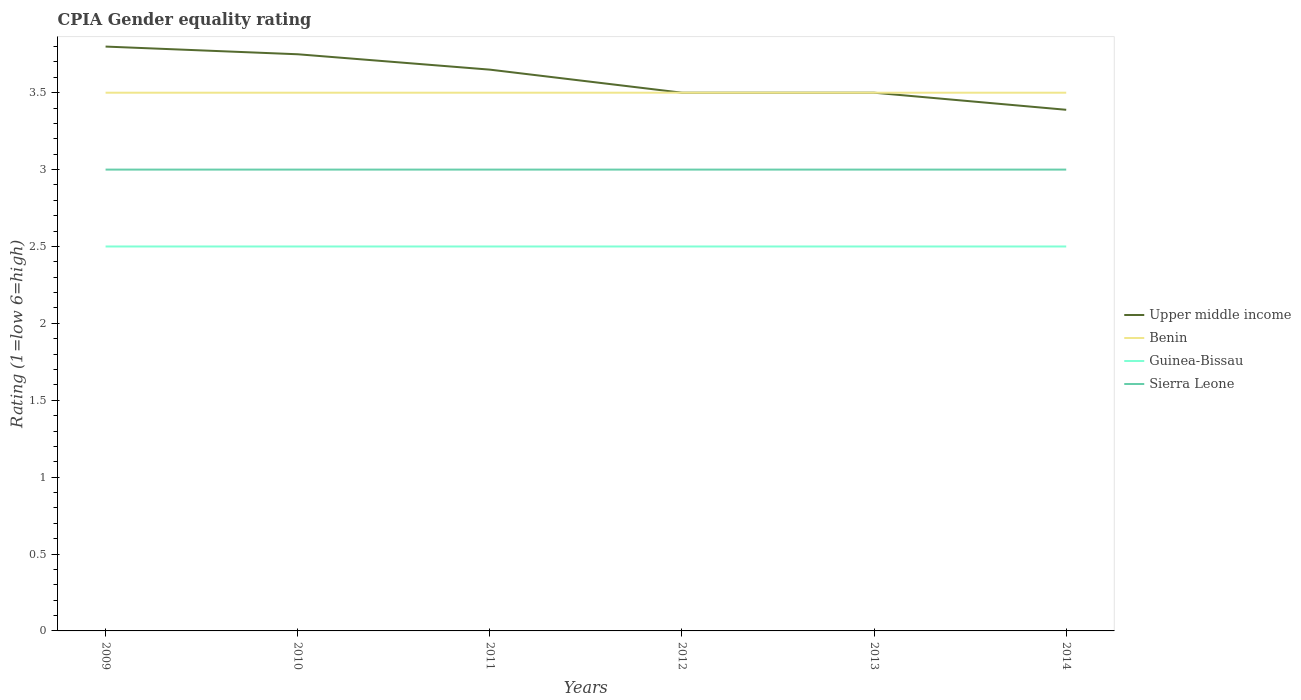Is the number of lines equal to the number of legend labels?
Give a very brief answer. Yes. Across all years, what is the maximum CPIA rating in Upper middle income?
Your response must be concise. 3.39. In which year was the CPIA rating in Upper middle income maximum?
Provide a succinct answer. 2014. What is the total CPIA rating in Benin in the graph?
Your answer should be very brief. 0. What is the difference between the highest and the second highest CPIA rating in Guinea-Bissau?
Make the answer very short. 0. What is the difference between two consecutive major ticks on the Y-axis?
Make the answer very short. 0.5. Does the graph contain grids?
Give a very brief answer. No. Where does the legend appear in the graph?
Provide a succinct answer. Center right. How many legend labels are there?
Keep it short and to the point. 4. How are the legend labels stacked?
Keep it short and to the point. Vertical. What is the title of the graph?
Offer a very short reply. CPIA Gender equality rating. Does "Low & middle income" appear as one of the legend labels in the graph?
Your response must be concise. No. What is the label or title of the X-axis?
Provide a short and direct response. Years. What is the Rating (1=low 6=high) in Upper middle income in 2009?
Give a very brief answer. 3.8. What is the Rating (1=low 6=high) in Guinea-Bissau in 2009?
Offer a terse response. 2.5. What is the Rating (1=low 6=high) of Sierra Leone in 2009?
Your answer should be very brief. 3. What is the Rating (1=low 6=high) in Upper middle income in 2010?
Ensure brevity in your answer.  3.75. What is the Rating (1=low 6=high) of Benin in 2010?
Your answer should be compact. 3.5. What is the Rating (1=low 6=high) of Sierra Leone in 2010?
Provide a succinct answer. 3. What is the Rating (1=low 6=high) in Upper middle income in 2011?
Your answer should be compact. 3.65. What is the Rating (1=low 6=high) in Benin in 2011?
Offer a very short reply. 3.5. What is the Rating (1=low 6=high) in Sierra Leone in 2011?
Offer a terse response. 3. What is the Rating (1=low 6=high) of Sierra Leone in 2012?
Keep it short and to the point. 3. What is the Rating (1=low 6=high) in Upper middle income in 2013?
Keep it short and to the point. 3.5. What is the Rating (1=low 6=high) in Benin in 2013?
Ensure brevity in your answer.  3.5. What is the Rating (1=low 6=high) in Guinea-Bissau in 2013?
Keep it short and to the point. 2.5. What is the Rating (1=low 6=high) of Upper middle income in 2014?
Offer a very short reply. 3.39. Across all years, what is the maximum Rating (1=low 6=high) of Upper middle income?
Offer a terse response. 3.8. Across all years, what is the maximum Rating (1=low 6=high) in Benin?
Offer a terse response. 3.5. Across all years, what is the maximum Rating (1=low 6=high) in Guinea-Bissau?
Your answer should be very brief. 2.5. Across all years, what is the minimum Rating (1=low 6=high) of Upper middle income?
Offer a very short reply. 3.39. Across all years, what is the minimum Rating (1=low 6=high) in Guinea-Bissau?
Provide a succinct answer. 2.5. What is the total Rating (1=low 6=high) in Upper middle income in the graph?
Provide a short and direct response. 21.59. What is the total Rating (1=low 6=high) of Sierra Leone in the graph?
Your answer should be very brief. 18. What is the difference between the Rating (1=low 6=high) in Benin in 2009 and that in 2010?
Provide a succinct answer. 0. What is the difference between the Rating (1=low 6=high) of Upper middle income in 2009 and that in 2011?
Offer a very short reply. 0.15. What is the difference between the Rating (1=low 6=high) in Benin in 2009 and that in 2011?
Give a very brief answer. 0. What is the difference between the Rating (1=low 6=high) of Guinea-Bissau in 2009 and that in 2011?
Your answer should be compact. 0. What is the difference between the Rating (1=low 6=high) in Benin in 2009 and that in 2012?
Keep it short and to the point. 0. What is the difference between the Rating (1=low 6=high) of Sierra Leone in 2009 and that in 2012?
Your answer should be very brief. 0. What is the difference between the Rating (1=low 6=high) of Guinea-Bissau in 2009 and that in 2013?
Provide a short and direct response. 0. What is the difference between the Rating (1=low 6=high) in Upper middle income in 2009 and that in 2014?
Provide a succinct answer. 0.41. What is the difference between the Rating (1=low 6=high) in Benin in 2009 and that in 2014?
Give a very brief answer. 0. What is the difference between the Rating (1=low 6=high) of Guinea-Bissau in 2009 and that in 2014?
Offer a very short reply. 0. What is the difference between the Rating (1=low 6=high) in Sierra Leone in 2009 and that in 2014?
Provide a succinct answer. 0. What is the difference between the Rating (1=low 6=high) of Benin in 2010 and that in 2011?
Offer a very short reply. 0. What is the difference between the Rating (1=low 6=high) of Sierra Leone in 2010 and that in 2011?
Offer a terse response. 0. What is the difference between the Rating (1=low 6=high) of Upper middle income in 2010 and that in 2012?
Your answer should be compact. 0.25. What is the difference between the Rating (1=low 6=high) of Benin in 2010 and that in 2012?
Keep it short and to the point. 0. What is the difference between the Rating (1=low 6=high) of Guinea-Bissau in 2010 and that in 2012?
Provide a short and direct response. 0. What is the difference between the Rating (1=low 6=high) in Benin in 2010 and that in 2013?
Provide a short and direct response. 0. What is the difference between the Rating (1=low 6=high) in Guinea-Bissau in 2010 and that in 2013?
Offer a terse response. 0. What is the difference between the Rating (1=low 6=high) in Sierra Leone in 2010 and that in 2013?
Keep it short and to the point. 0. What is the difference between the Rating (1=low 6=high) of Upper middle income in 2010 and that in 2014?
Offer a very short reply. 0.36. What is the difference between the Rating (1=low 6=high) of Benin in 2010 and that in 2014?
Your answer should be compact. 0. What is the difference between the Rating (1=low 6=high) in Guinea-Bissau in 2010 and that in 2014?
Give a very brief answer. 0. What is the difference between the Rating (1=low 6=high) in Upper middle income in 2011 and that in 2012?
Your response must be concise. 0.15. What is the difference between the Rating (1=low 6=high) in Benin in 2011 and that in 2012?
Offer a terse response. 0. What is the difference between the Rating (1=low 6=high) of Upper middle income in 2011 and that in 2014?
Ensure brevity in your answer.  0.26. What is the difference between the Rating (1=low 6=high) in Upper middle income in 2013 and that in 2014?
Your response must be concise. 0.11. What is the difference between the Rating (1=low 6=high) of Upper middle income in 2009 and the Rating (1=low 6=high) of Benin in 2010?
Ensure brevity in your answer.  0.3. What is the difference between the Rating (1=low 6=high) in Upper middle income in 2009 and the Rating (1=low 6=high) in Sierra Leone in 2010?
Provide a short and direct response. 0.8. What is the difference between the Rating (1=low 6=high) of Upper middle income in 2009 and the Rating (1=low 6=high) of Benin in 2011?
Keep it short and to the point. 0.3. What is the difference between the Rating (1=low 6=high) in Upper middle income in 2009 and the Rating (1=low 6=high) in Guinea-Bissau in 2011?
Your answer should be very brief. 1.3. What is the difference between the Rating (1=low 6=high) of Benin in 2009 and the Rating (1=low 6=high) of Sierra Leone in 2011?
Your answer should be very brief. 0.5. What is the difference between the Rating (1=low 6=high) of Upper middle income in 2009 and the Rating (1=low 6=high) of Guinea-Bissau in 2012?
Offer a very short reply. 1.3. What is the difference between the Rating (1=low 6=high) of Benin in 2009 and the Rating (1=low 6=high) of Guinea-Bissau in 2012?
Ensure brevity in your answer.  1. What is the difference between the Rating (1=low 6=high) of Benin in 2009 and the Rating (1=low 6=high) of Sierra Leone in 2012?
Make the answer very short. 0.5. What is the difference between the Rating (1=low 6=high) of Upper middle income in 2009 and the Rating (1=low 6=high) of Benin in 2013?
Provide a succinct answer. 0.3. What is the difference between the Rating (1=low 6=high) of Upper middle income in 2009 and the Rating (1=low 6=high) of Guinea-Bissau in 2013?
Provide a succinct answer. 1.3. What is the difference between the Rating (1=low 6=high) in Benin in 2009 and the Rating (1=low 6=high) in Guinea-Bissau in 2013?
Your answer should be very brief. 1. What is the difference between the Rating (1=low 6=high) in Benin in 2009 and the Rating (1=low 6=high) in Sierra Leone in 2013?
Your answer should be very brief. 0.5. What is the difference between the Rating (1=low 6=high) in Benin in 2009 and the Rating (1=low 6=high) in Guinea-Bissau in 2014?
Offer a terse response. 1. What is the difference between the Rating (1=low 6=high) in Guinea-Bissau in 2009 and the Rating (1=low 6=high) in Sierra Leone in 2014?
Give a very brief answer. -0.5. What is the difference between the Rating (1=low 6=high) of Upper middle income in 2010 and the Rating (1=low 6=high) of Sierra Leone in 2011?
Provide a succinct answer. 0.75. What is the difference between the Rating (1=low 6=high) in Benin in 2010 and the Rating (1=low 6=high) in Sierra Leone in 2011?
Your response must be concise. 0.5. What is the difference between the Rating (1=low 6=high) of Guinea-Bissau in 2010 and the Rating (1=low 6=high) of Sierra Leone in 2011?
Ensure brevity in your answer.  -0.5. What is the difference between the Rating (1=low 6=high) of Upper middle income in 2010 and the Rating (1=low 6=high) of Benin in 2012?
Provide a succinct answer. 0.25. What is the difference between the Rating (1=low 6=high) in Upper middle income in 2010 and the Rating (1=low 6=high) in Sierra Leone in 2012?
Offer a very short reply. 0.75. What is the difference between the Rating (1=low 6=high) in Benin in 2010 and the Rating (1=low 6=high) in Sierra Leone in 2012?
Offer a very short reply. 0.5. What is the difference between the Rating (1=low 6=high) in Guinea-Bissau in 2010 and the Rating (1=low 6=high) in Sierra Leone in 2012?
Your answer should be very brief. -0.5. What is the difference between the Rating (1=low 6=high) in Upper middle income in 2010 and the Rating (1=low 6=high) in Benin in 2013?
Your response must be concise. 0.25. What is the difference between the Rating (1=low 6=high) of Upper middle income in 2010 and the Rating (1=low 6=high) of Guinea-Bissau in 2013?
Provide a succinct answer. 1.25. What is the difference between the Rating (1=low 6=high) in Benin in 2010 and the Rating (1=low 6=high) in Guinea-Bissau in 2013?
Offer a very short reply. 1. What is the difference between the Rating (1=low 6=high) in Benin in 2010 and the Rating (1=low 6=high) in Guinea-Bissau in 2014?
Make the answer very short. 1. What is the difference between the Rating (1=low 6=high) in Benin in 2010 and the Rating (1=low 6=high) in Sierra Leone in 2014?
Provide a short and direct response. 0.5. What is the difference between the Rating (1=low 6=high) of Guinea-Bissau in 2010 and the Rating (1=low 6=high) of Sierra Leone in 2014?
Your answer should be compact. -0.5. What is the difference between the Rating (1=low 6=high) of Upper middle income in 2011 and the Rating (1=low 6=high) of Guinea-Bissau in 2012?
Offer a very short reply. 1.15. What is the difference between the Rating (1=low 6=high) of Upper middle income in 2011 and the Rating (1=low 6=high) of Sierra Leone in 2012?
Keep it short and to the point. 0.65. What is the difference between the Rating (1=low 6=high) in Benin in 2011 and the Rating (1=low 6=high) in Sierra Leone in 2012?
Keep it short and to the point. 0.5. What is the difference between the Rating (1=low 6=high) in Upper middle income in 2011 and the Rating (1=low 6=high) in Benin in 2013?
Keep it short and to the point. 0.15. What is the difference between the Rating (1=low 6=high) in Upper middle income in 2011 and the Rating (1=low 6=high) in Guinea-Bissau in 2013?
Offer a very short reply. 1.15. What is the difference between the Rating (1=low 6=high) in Upper middle income in 2011 and the Rating (1=low 6=high) in Sierra Leone in 2013?
Offer a terse response. 0.65. What is the difference between the Rating (1=low 6=high) of Benin in 2011 and the Rating (1=low 6=high) of Guinea-Bissau in 2013?
Provide a short and direct response. 1. What is the difference between the Rating (1=low 6=high) of Guinea-Bissau in 2011 and the Rating (1=low 6=high) of Sierra Leone in 2013?
Your response must be concise. -0.5. What is the difference between the Rating (1=low 6=high) in Upper middle income in 2011 and the Rating (1=low 6=high) in Guinea-Bissau in 2014?
Your response must be concise. 1.15. What is the difference between the Rating (1=low 6=high) of Upper middle income in 2011 and the Rating (1=low 6=high) of Sierra Leone in 2014?
Keep it short and to the point. 0.65. What is the difference between the Rating (1=low 6=high) of Benin in 2011 and the Rating (1=low 6=high) of Guinea-Bissau in 2014?
Make the answer very short. 1. What is the difference between the Rating (1=low 6=high) in Guinea-Bissau in 2011 and the Rating (1=low 6=high) in Sierra Leone in 2014?
Keep it short and to the point. -0.5. What is the difference between the Rating (1=low 6=high) in Upper middle income in 2012 and the Rating (1=low 6=high) in Benin in 2013?
Provide a short and direct response. 0. What is the difference between the Rating (1=low 6=high) in Upper middle income in 2012 and the Rating (1=low 6=high) in Sierra Leone in 2013?
Your answer should be very brief. 0.5. What is the difference between the Rating (1=low 6=high) of Benin in 2012 and the Rating (1=low 6=high) of Guinea-Bissau in 2013?
Offer a terse response. 1. What is the difference between the Rating (1=low 6=high) in Benin in 2012 and the Rating (1=low 6=high) in Sierra Leone in 2013?
Provide a succinct answer. 0.5. What is the difference between the Rating (1=low 6=high) in Guinea-Bissau in 2012 and the Rating (1=low 6=high) in Sierra Leone in 2013?
Your response must be concise. -0.5. What is the difference between the Rating (1=low 6=high) of Upper middle income in 2012 and the Rating (1=low 6=high) of Benin in 2014?
Provide a succinct answer. 0. What is the difference between the Rating (1=low 6=high) in Guinea-Bissau in 2012 and the Rating (1=low 6=high) in Sierra Leone in 2014?
Provide a succinct answer. -0.5. What is the difference between the Rating (1=low 6=high) in Upper middle income in 2013 and the Rating (1=low 6=high) in Guinea-Bissau in 2014?
Your answer should be very brief. 1. What is the difference between the Rating (1=low 6=high) in Benin in 2013 and the Rating (1=low 6=high) in Guinea-Bissau in 2014?
Provide a short and direct response. 1. What is the difference between the Rating (1=low 6=high) in Benin in 2013 and the Rating (1=low 6=high) in Sierra Leone in 2014?
Make the answer very short. 0.5. What is the difference between the Rating (1=low 6=high) of Guinea-Bissau in 2013 and the Rating (1=low 6=high) of Sierra Leone in 2014?
Give a very brief answer. -0.5. What is the average Rating (1=low 6=high) of Upper middle income per year?
Your answer should be compact. 3.6. What is the average Rating (1=low 6=high) in Benin per year?
Offer a terse response. 3.5. What is the average Rating (1=low 6=high) in Sierra Leone per year?
Give a very brief answer. 3. In the year 2009, what is the difference between the Rating (1=low 6=high) of Upper middle income and Rating (1=low 6=high) of Guinea-Bissau?
Your answer should be very brief. 1.3. In the year 2009, what is the difference between the Rating (1=low 6=high) in Upper middle income and Rating (1=low 6=high) in Sierra Leone?
Ensure brevity in your answer.  0.8. In the year 2009, what is the difference between the Rating (1=low 6=high) in Benin and Rating (1=low 6=high) in Guinea-Bissau?
Give a very brief answer. 1. In the year 2009, what is the difference between the Rating (1=low 6=high) in Benin and Rating (1=low 6=high) in Sierra Leone?
Offer a very short reply. 0.5. In the year 2010, what is the difference between the Rating (1=low 6=high) in Upper middle income and Rating (1=low 6=high) in Benin?
Make the answer very short. 0.25. In the year 2010, what is the difference between the Rating (1=low 6=high) in Upper middle income and Rating (1=low 6=high) in Sierra Leone?
Make the answer very short. 0.75. In the year 2010, what is the difference between the Rating (1=low 6=high) of Benin and Rating (1=low 6=high) of Guinea-Bissau?
Your answer should be very brief. 1. In the year 2010, what is the difference between the Rating (1=low 6=high) in Benin and Rating (1=low 6=high) in Sierra Leone?
Provide a succinct answer. 0.5. In the year 2011, what is the difference between the Rating (1=low 6=high) in Upper middle income and Rating (1=low 6=high) in Benin?
Provide a succinct answer. 0.15. In the year 2011, what is the difference between the Rating (1=low 6=high) of Upper middle income and Rating (1=low 6=high) of Guinea-Bissau?
Offer a terse response. 1.15. In the year 2011, what is the difference between the Rating (1=low 6=high) of Upper middle income and Rating (1=low 6=high) of Sierra Leone?
Keep it short and to the point. 0.65. In the year 2011, what is the difference between the Rating (1=low 6=high) of Benin and Rating (1=low 6=high) of Sierra Leone?
Provide a succinct answer. 0.5. In the year 2011, what is the difference between the Rating (1=low 6=high) of Guinea-Bissau and Rating (1=low 6=high) of Sierra Leone?
Make the answer very short. -0.5. In the year 2012, what is the difference between the Rating (1=low 6=high) of Benin and Rating (1=low 6=high) of Guinea-Bissau?
Provide a short and direct response. 1. In the year 2013, what is the difference between the Rating (1=low 6=high) in Upper middle income and Rating (1=low 6=high) in Guinea-Bissau?
Offer a terse response. 1. In the year 2013, what is the difference between the Rating (1=low 6=high) of Upper middle income and Rating (1=low 6=high) of Sierra Leone?
Your answer should be very brief. 0.5. In the year 2013, what is the difference between the Rating (1=low 6=high) in Benin and Rating (1=low 6=high) in Guinea-Bissau?
Ensure brevity in your answer.  1. In the year 2013, what is the difference between the Rating (1=low 6=high) in Benin and Rating (1=low 6=high) in Sierra Leone?
Offer a very short reply. 0.5. In the year 2013, what is the difference between the Rating (1=low 6=high) in Guinea-Bissau and Rating (1=low 6=high) in Sierra Leone?
Give a very brief answer. -0.5. In the year 2014, what is the difference between the Rating (1=low 6=high) in Upper middle income and Rating (1=low 6=high) in Benin?
Make the answer very short. -0.11. In the year 2014, what is the difference between the Rating (1=low 6=high) in Upper middle income and Rating (1=low 6=high) in Sierra Leone?
Offer a very short reply. 0.39. What is the ratio of the Rating (1=low 6=high) in Upper middle income in 2009 to that in 2010?
Offer a terse response. 1.01. What is the ratio of the Rating (1=low 6=high) in Benin in 2009 to that in 2010?
Your answer should be compact. 1. What is the ratio of the Rating (1=low 6=high) of Guinea-Bissau in 2009 to that in 2010?
Your answer should be compact. 1. What is the ratio of the Rating (1=low 6=high) of Upper middle income in 2009 to that in 2011?
Provide a succinct answer. 1.04. What is the ratio of the Rating (1=low 6=high) of Upper middle income in 2009 to that in 2012?
Make the answer very short. 1.09. What is the ratio of the Rating (1=low 6=high) of Guinea-Bissau in 2009 to that in 2012?
Offer a terse response. 1. What is the ratio of the Rating (1=low 6=high) in Sierra Leone in 2009 to that in 2012?
Make the answer very short. 1. What is the ratio of the Rating (1=low 6=high) in Upper middle income in 2009 to that in 2013?
Provide a short and direct response. 1.09. What is the ratio of the Rating (1=low 6=high) of Benin in 2009 to that in 2013?
Ensure brevity in your answer.  1. What is the ratio of the Rating (1=low 6=high) of Guinea-Bissau in 2009 to that in 2013?
Give a very brief answer. 1. What is the ratio of the Rating (1=low 6=high) in Upper middle income in 2009 to that in 2014?
Make the answer very short. 1.12. What is the ratio of the Rating (1=low 6=high) in Upper middle income in 2010 to that in 2011?
Keep it short and to the point. 1.03. What is the ratio of the Rating (1=low 6=high) in Upper middle income in 2010 to that in 2012?
Your answer should be compact. 1.07. What is the ratio of the Rating (1=low 6=high) in Benin in 2010 to that in 2012?
Offer a terse response. 1. What is the ratio of the Rating (1=low 6=high) of Upper middle income in 2010 to that in 2013?
Your answer should be compact. 1.07. What is the ratio of the Rating (1=low 6=high) of Sierra Leone in 2010 to that in 2013?
Your answer should be compact. 1. What is the ratio of the Rating (1=low 6=high) in Upper middle income in 2010 to that in 2014?
Provide a succinct answer. 1.11. What is the ratio of the Rating (1=low 6=high) in Upper middle income in 2011 to that in 2012?
Make the answer very short. 1.04. What is the ratio of the Rating (1=low 6=high) in Benin in 2011 to that in 2012?
Your response must be concise. 1. What is the ratio of the Rating (1=low 6=high) in Sierra Leone in 2011 to that in 2012?
Make the answer very short. 1. What is the ratio of the Rating (1=low 6=high) in Upper middle income in 2011 to that in 2013?
Ensure brevity in your answer.  1.04. What is the ratio of the Rating (1=low 6=high) in Upper middle income in 2011 to that in 2014?
Keep it short and to the point. 1.08. What is the ratio of the Rating (1=low 6=high) in Benin in 2012 to that in 2013?
Keep it short and to the point. 1. What is the ratio of the Rating (1=low 6=high) in Guinea-Bissau in 2012 to that in 2013?
Provide a short and direct response. 1. What is the ratio of the Rating (1=low 6=high) in Upper middle income in 2012 to that in 2014?
Offer a terse response. 1.03. What is the ratio of the Rating (1=low 6=high) of Benin in 2012 to that in 2014?
Offer a terse response. 1. What is the ratio of the Rating (1=low 6=high) of Sierra Leone in 2012 to that in 2014?
Offer a very short reply. 1. What is the ratio of the Rating (1=low 6=high) in Upper middle income in 2013 to that in 2014?
Your answer should be compact. 1.03. What is the ratio of the Rating (1=low 6=high) in Sierra Leone in 2013 to that in 2014?
Provide a succinct answer. 1. What is the difference between the highest and the second highest Rating (1=low 6=high) of Upper middle income?
Give a very brief answer. 0.05. What is the difference between the highest and the second highest Rating (1=low 6=high) of Benin?
Offer a terse response. 0. What is the difference between the highest and the second highest Rating (1=low 6=high) in Guinea-Bissau?
Your response must be concise. 0. What is the difference between the highest and the lowest Rating (1=low 6=high) of Upper middle income?
Your response must be concise. 0.41. What is the difference between the highest and the lowest Rating (1=low 6=high) of Guinea-Bissau?
Offer a very short reply. 0. 